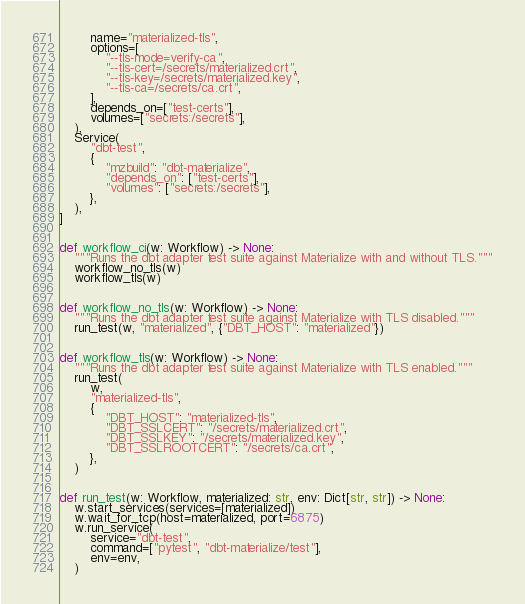Convert code to text. <code><loc_0><loc_0><loc_500><loc_500><_Python_>        name="materialized-tls",
        options=[
            "--tls-mode=verify-ca",
            "--tls-cert=/secrets/materialized.crt",
            "--tls-key=/secrets/materialized.key",
            "--tls-ca=/secrets/ca.crt",
        ],
        depends_on=["test-certs"],
        volumes=["secrets:/secrets"],
    ),
    Service(
        "dbt-test",
        {
            "mzbuild": "dbt-materialize",
            "depends_on": ["test-certs"],
            "volumes": ["secrets:/secrets"],
        },
    ),
]


def workflow_ci(w: Workflow) -> None:
    """Runs the dbt adapter test suite against Materialize with and without TLS."""
    workflow_no_tls(w)
    workflow_tls(w)


def workflow_no_tls(w: Workflow) -> None:
    """Runs the dbt adapter test suite against Materialize with TLS disabled."""
    run_test(w, "materialized", {"DBT_HOST": "materialized"})


def workflow_tls(w: Workflow) -> None:
    """Runs the dbt adapter test suite against Materialize with TLS enabled."""
    run_test(
        w,
        "materialized-tls",
        {
            "DBT_HOST": "materialized-tls",
            "DBT_SSLCERT": "/secrets/materialized.crt",
            "DBT_SSLKEY": "/secrets/materialized.key",
            "DBT_SSLROOTCERT": "/secrets/ca.crt",
        },
    )


def run_test(w: Workflow, materialized: str, env: Dict[str, str]) -> None:
    w.start_services(services=[materialized])
    w.wait_for_tcp(host=materialized, port=6875)
    w.run_service(
        service="dbt-test",
        command=["pytest", "dbt-materialize/test"],
        env=env,
    )
</code> 